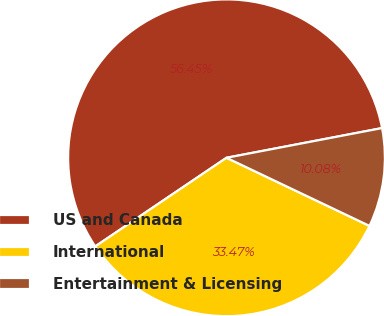Convert chart to OTSL. <chart><loc_0><loc_0><loc_500><loc_500><pie_chart><fcel>US and Canada<fcel>International<fcel>Entertainment & Licensing<nl><fcel>56.45%<fcel>33.47%<fcel>10.08%<nl></chart> 